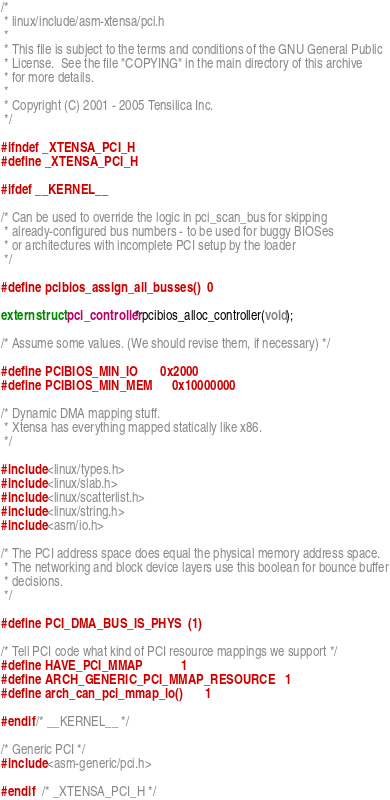Convert code to text. <code><loc_0><loc_0><loc_500><loc_500><_C_>/*
 * linux/include/asm-xtensa/pci.h
 *
 * This file is subject to the terms and conditions of the GNU General Public
 * License.  See the file "COPYING" in the main directory of this archive
 * for more details.
 *
 * Copyright (C) 2001 - 2005 Tensilica Inc.
 */

#ifndef _XTENSA_PCI_H
#define _XTENSA_PCI_H

#ifdef __KERNEL__

/* Can be used to override the logic in pci_scan_bus for skipping
 * already-configured bus numbers - to be used for buggy BIOSes
 * or architectures with incomplete PCI setup by the loader
 */

#define pcibios_assign_all_busses()	0

extern struct pci_controller* pcibios_alloc_controller(void);

/* Assume some values. (We should revise them, if necessary) */

#define PCIBIOS_MIN_IO		0x2000
#define PCIBIOS_MIN_MEM		0x10000000

/* Dynamic DMA mapping stuff.
 * Xtensa has everything mapped statically like x86.
 */

#include <linux/types.h>
#include <linux/slab.h>
#include <linux/scatterlist.h>
#include <linux/string.h>
#include <asm/io.h>

/* The PCI address space does equal the physical memory address space.
 * The networking and block device layers use this boolean for bounce buffer
 * decisions.
 */

#define PCI_DMA_BUS_IS_PHYS	(1)

/* Tell PCI code what kind of PCI resource mappings we support */
#define HAVE_PCI_MMAP			1
#define ARCH_GENERIC_PCI_MMAP_RESOURCE	1
#define arch_can_pci_mmap_io()		1

#endif /* __KERNEL__ */

/* Generic PCI */
#include <asm-generic/pci.h>

#endif	/* _XTENSA_PCI_H */
</code> 